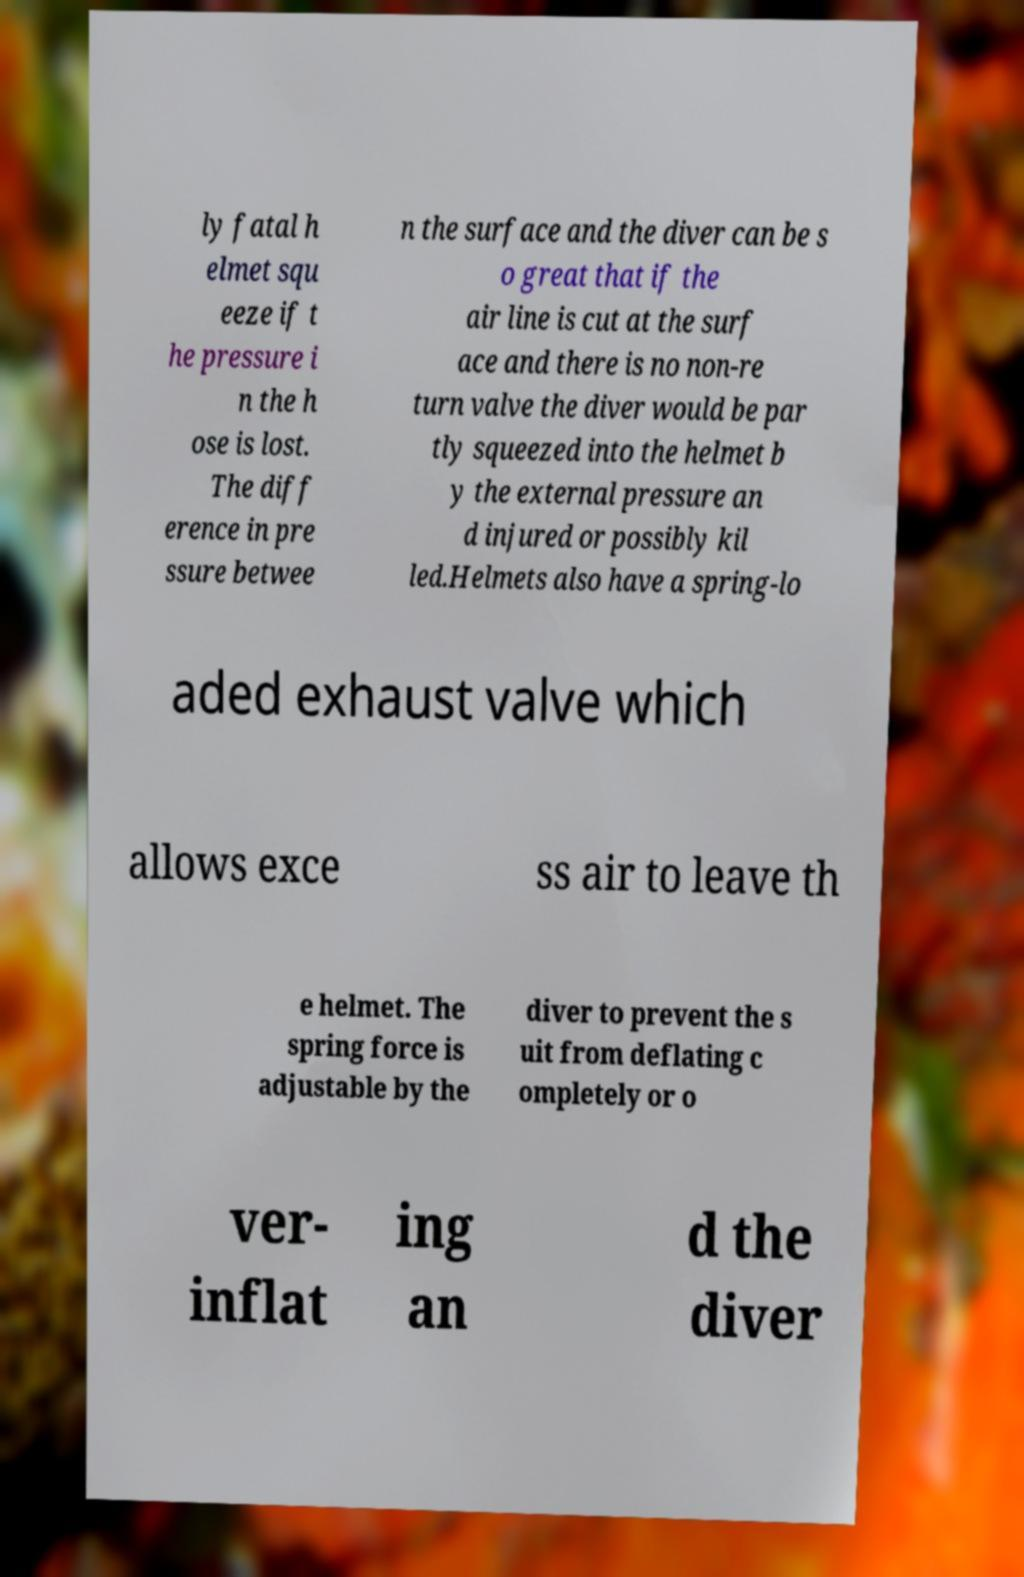Please read and relay the text visible in this image. What does it say? ly fatal h elmet squ eeze if t he pressure i n the h ose is lost. The diff erence in pre ssure betwee n the surface and the diver can be s o great that if the air line is cut at the surf ace and there is no non-re turn valve the diver would be par tly squeezed into the helmet b y the external pressure an d injured or possibly kil led.Helmets also have a spring-lo aded exhaust valve which allows exce ss air to leave th e helmet. The spring force is adjustable by the diver to prevent the s uit from deflating c ompletely or o ver- inflat ing an d the diver 